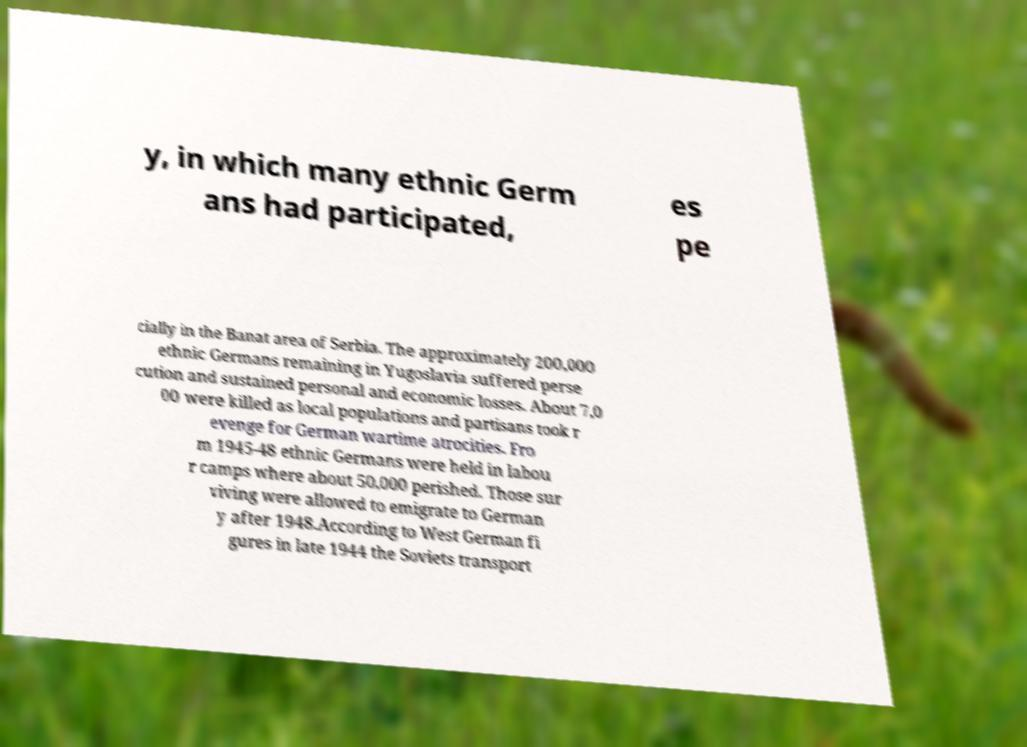Please read and relay the text visible in this image. What does it say? y, in which many ethnic Germ ans had participated, es pe cially in the Banat area of Serbia. The approximately 200,000 ethnic Germans remaining in Yugoslavia suffered perse cution and sustained personal and economic losses. About 7,0 00 were killed as local populations and partisans took r evenge for German wartime atrocities. Fro m 1945-48 ethnic Germans were held in labou r camps where about 50,000 perished. Those sur viving were allowed to emigrate to German y after 1948.According to West German fi gures in late 1944 the Soviets transport 